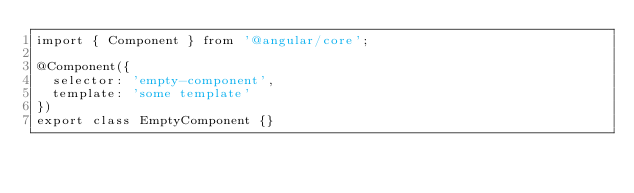Convert code to text. <code><loc_0><loc_0><loc_500><loc_500><_TypeScript_>import { Component } from '@angular/core';

@Component({
  selector: 'empty-component',
  template: 'some template'
})
export class EmptyComponent {}
</code> 